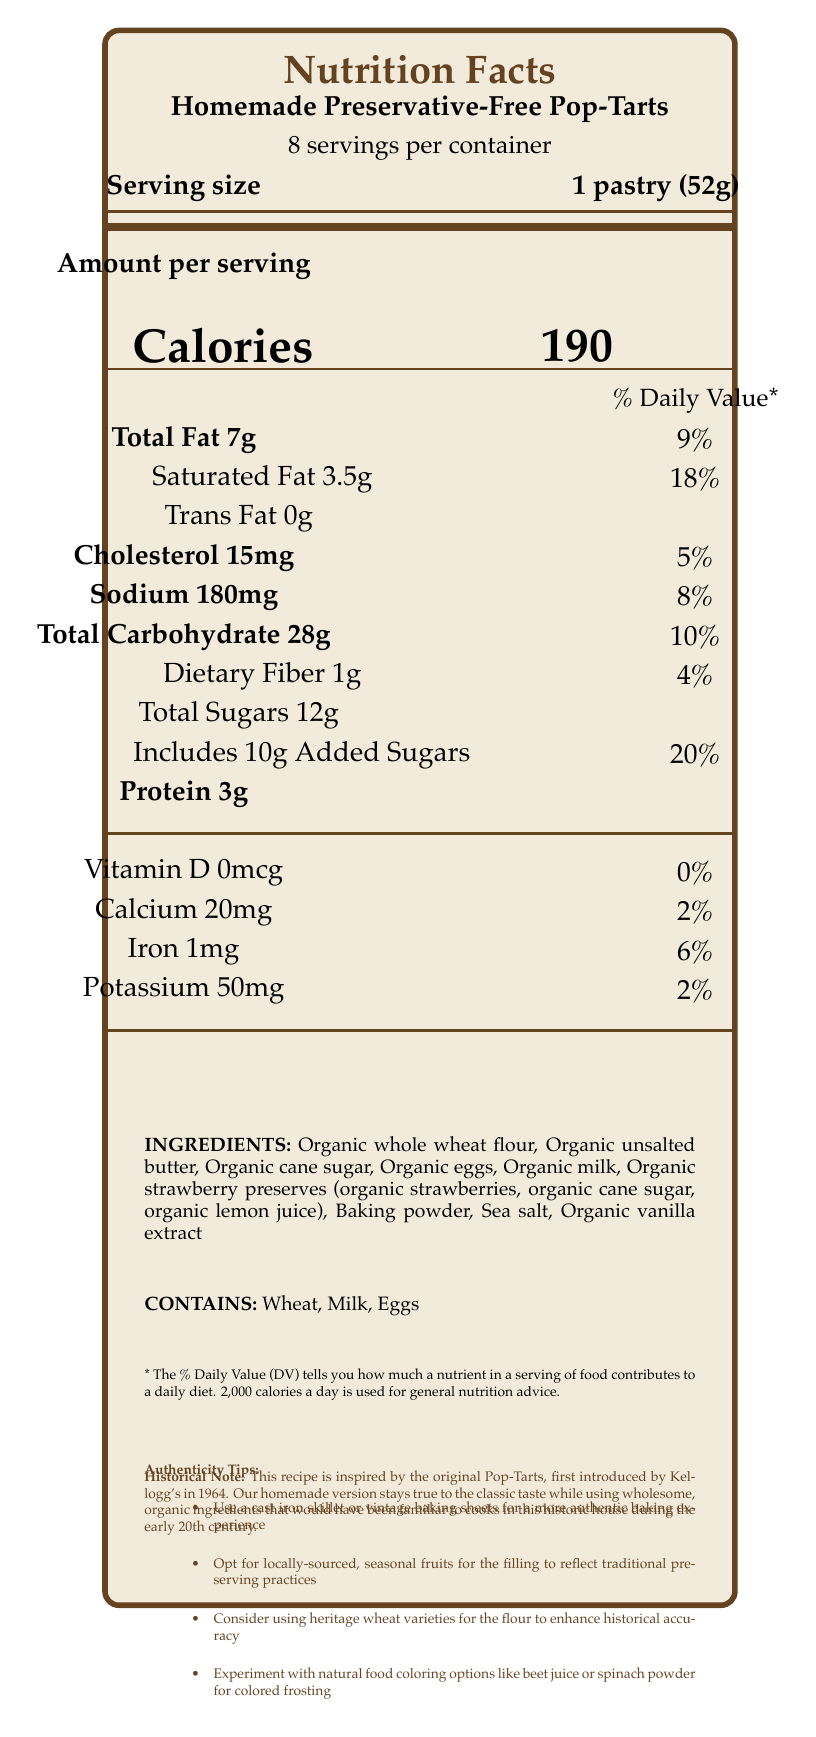what is the serving size for Homemade Preservative-Free Pop-Tarts? The serving size is specified directly under the product title as "1 pastry (52g)".
Answer: 1 pastry (52g) How many servings are there per container? Under the product name, it states "8 servings per container".
Answer: 8 How many calories are there per serving? Located centrally under the "Amount per serving" section, it specifies "Calories 190".
Answer: 190 What is the amount of protein per serving? The protein amount is found near the bottom of the amount per serving section and is listed as "Protein 3g".
Answer: 3g Does the product contain any trans fat? The amount of trans fat per serving is stated as "Trans Fat 0g".
Answer: 0g What is the daily value percentage for calcium? A. 2% B. 6% C. 10% D. 20% The daily value percentage for calcium is 2%, as stated next to "Calcium 20mg".
Answer: A Which of the following is NOT an ingredient in the product? A. Organic whole wheat flour B. Organic unsalted butter C. High-fructose corn syrup D. Organic eggs High-fructose corn syrup is not listed among the ingredients. The document lists Organic whole wheat flour, Organic unsalted butter, and Organic eggs among others.
Answer: C Is Vitamin D present in this food product? The nutrition facts state "Vitamin D 0mcg" which implies no Vitamin D is present.
Answer: No What allergens are present in this product? The document lists the allergens under a specific section "CONTAINS" which mentions Wheat, Milk, and Eggs.
Answer: Wheat, Milk, Eggs Can the exact method of preparing this Homemade Preservative-Free Pop-Tart be determined from the document? The document provides nutrition facts and some tips for authenticity but does not include a detailed recipe or specific preparation method.
Answer: Not enough information How much added sugar is there per serving? Under the section "Total Sugars 12g", it also states "Includes 10g Added Sugars".
Answer: 10g What is one tip for maintaining historical accuracy while baking Homemade Preservative-Free Pop-Tarts? Tip found under "Authenticity Tips".
Answer: Use a cast iron skillet or vintage baking sheets Summarize the main idea of the document. This explanation is gathered from the various sections of the document, which include nutrition facts, tips for maintaining historical authenticity, ingredients, and allergen information.
Answer: The document provides the nutrition facts, ingredients, allergens, and some authenticity tips for a homemade, preservative-free version of Pop-Tarts, inspired by the original product introduced in 1964. 